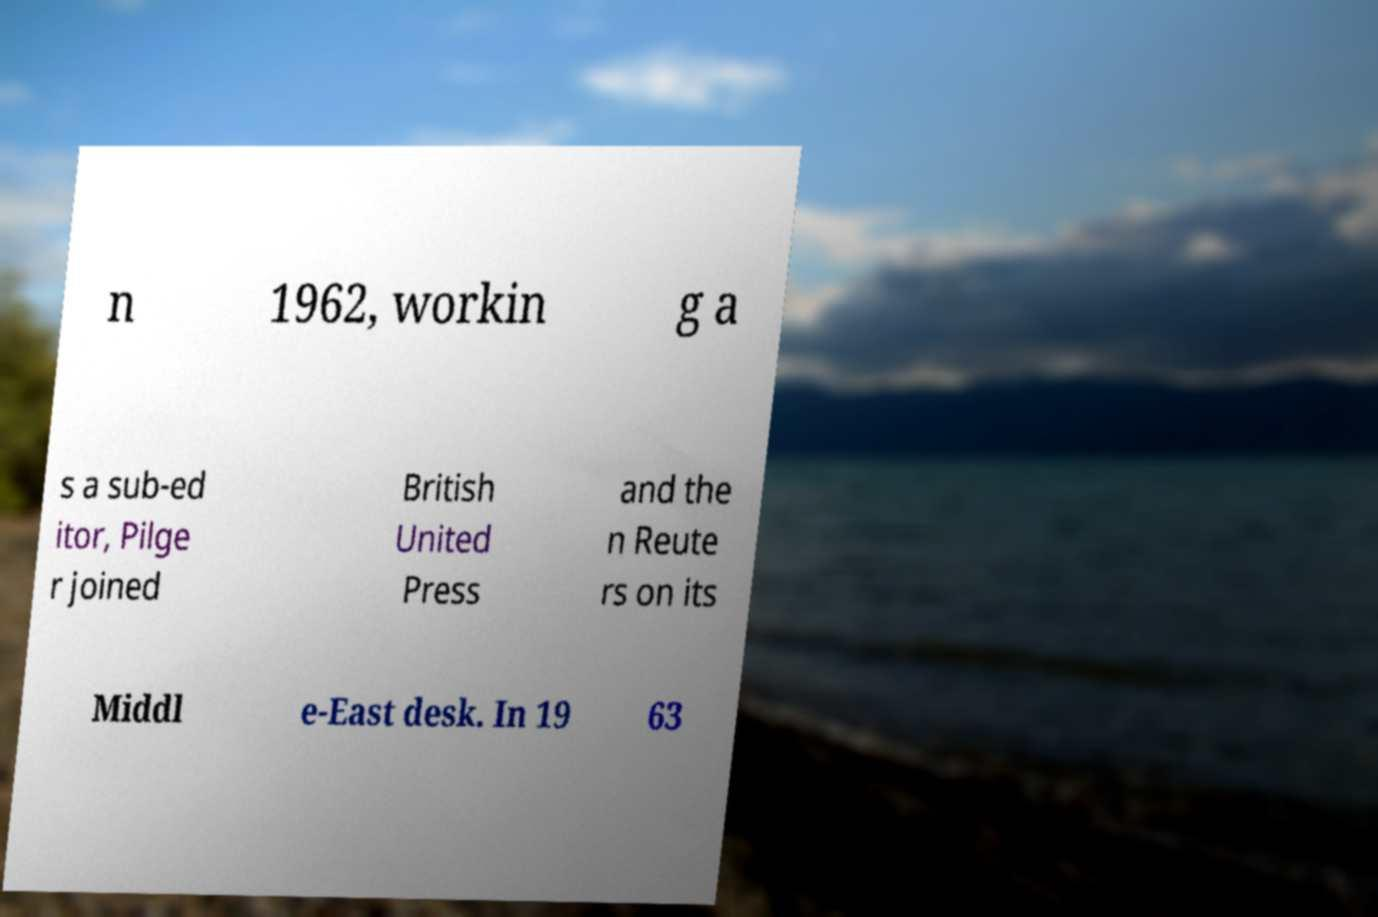Could you extract and type out the text from this image? n 1962, workin g a s a sub-ed itor, Pilge r joined British United Press and the n Reute rs on its Middl e-East desk. In 19 63 